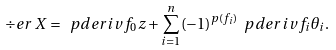Convert formula to latex. <formula><loc_0><loc_0><loc_500><loc_500>\div e r \, X = \ p d e r i v { f _ { 0 } } { z } + \sum _ { i = 1 } ^ { n } ( - 1 ) ^ { p ( f _ { i } ) } \ p d e r i v { f _ { i } } { \theta _ { i } } .</formula> 